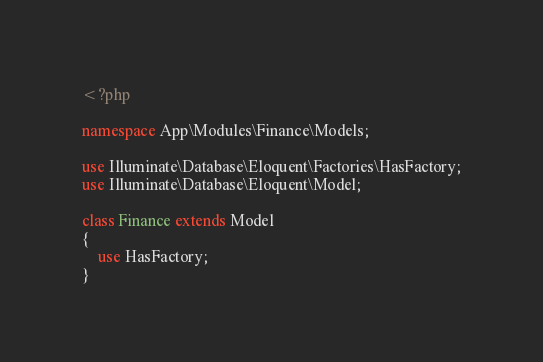<code> <loc_0><loc_0><loc_500><loc_500><_PHP_><?php

namespace App\Modules\Finance\Models;

use Illuminate\Database\Eloquent\Factories\HasFactory;
use Illuminate\Database\Eloquent\Model;

class Finance extends Model
{
    use HasFactory;
}
</code> 